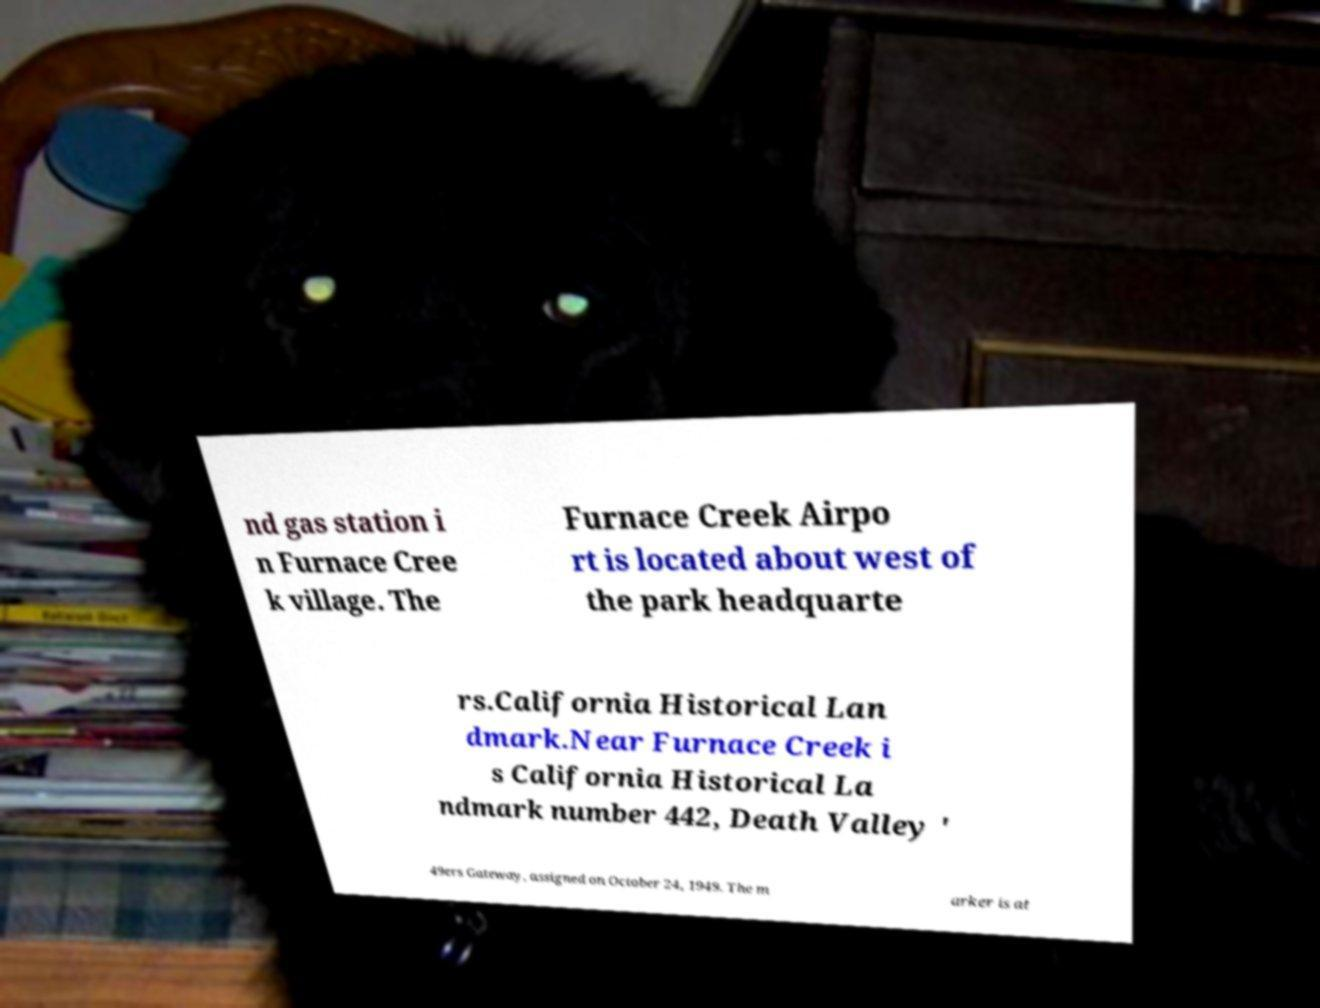I need the written content from this picture converted into text. Can you do that? nd gas station i n Furnace Cree k village. The Furnace Creek Airpo rt is located about west of the park headquarte rs.California Historical Lan dmark.Near Furnace Creek i s California Historical La ndmark number 442, Death Valley ' 49ers Gateway, assigned on October 24, 1949. The m arker is at 